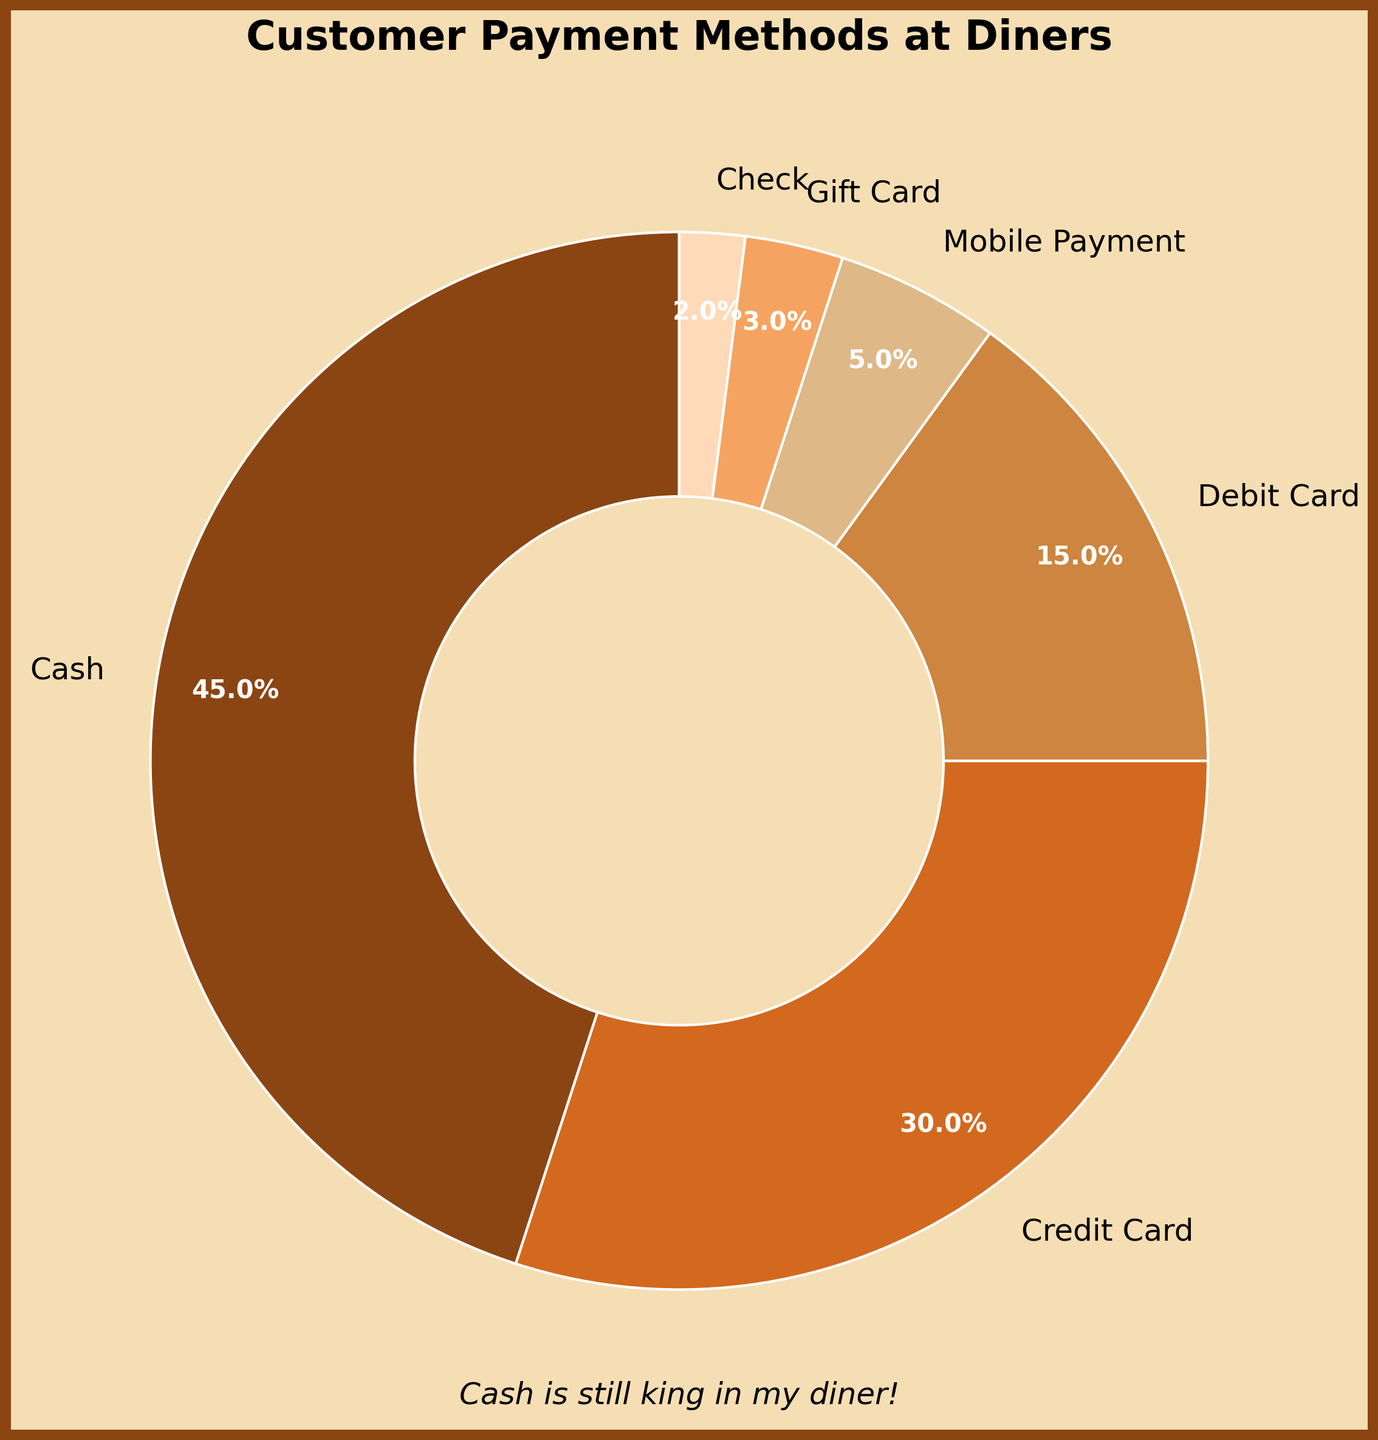What is the most popular payment method according to the pie chart? The pie chart shows different payment methods with their respective percentages. Cash has the highest percentage at 45%.
Answer: Cash What is the total percentage of payments made via credit and debit cards combined? The percentage of credit card payments is 30% and debit card payments is 15%. Adding these together, 30% + 15% = 45%.
Answer: 45% Which payment method is used the least by customers? The percentages for each payment method are shown. The smallest is Check at 2%.
Answer: Check How much more popular is cash than mobile payments? The percentage for cash payments is 45% and for mobile payments is 5%. Subtracting the two, 45% - 5% = 40%.
Answer: 40% Combine the percentages of mobile payment, gift card, and check. Is this combined figure greater than 10%? Mobile payment is 5%, gift card is 3%, and check is 2%. Adding them, 5% + 3% + 2% = 10%.
Answer: No, it is exactly 10% Is the percentage of debit card payments higher or lower than credit card payments? The pie chart shows 15% for debit card payments and 30% for credit card payments.
Answer: Lower Out of the provided payment methods, which two methods together make up exactly half the payments? Cash (45%) and Credit Card (30%) make a total of 75%, which is more than 50%. Similarly, no other two methods add up exactly to 50%.
Answer: None What is the visual element used to emphasize the 'Cash is still king in my diner!' subtitle? The subtitle is placed below the pie chart emphatically and styled in italic.
Answer: Italic style Between cash and gift card payments, which has a larger share and by how much? Cash has 45% and Gift Card has 3%. The difference is 45% - 3% = 42%.
Answer: Cash by 42% 